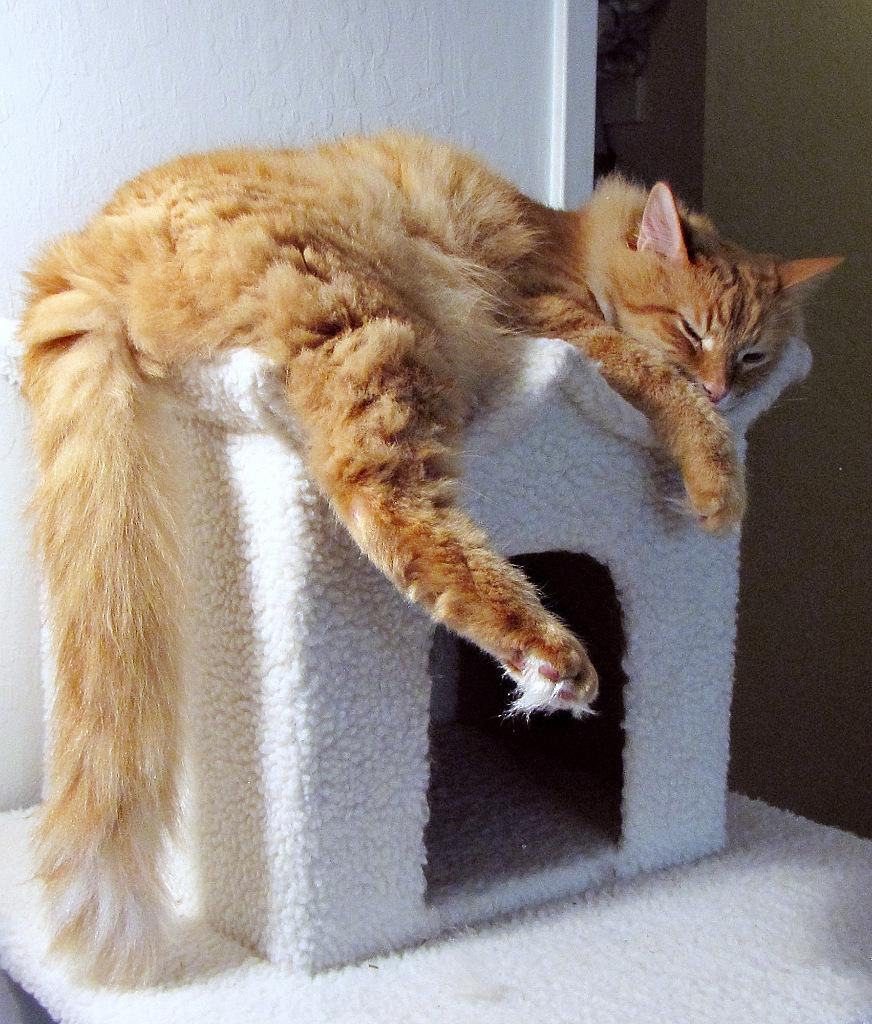What type of animal is in the image? There is a cat in the image. What is the cat lying on? The cat is lying on a pet house. What can be seen in the background of the image? There are walls visible in the background of the image. What type of surprise does the man have for the robin in the image? There is no man or robin present in the image; it only features a cat lying on a pet house with walls visible in the background. 